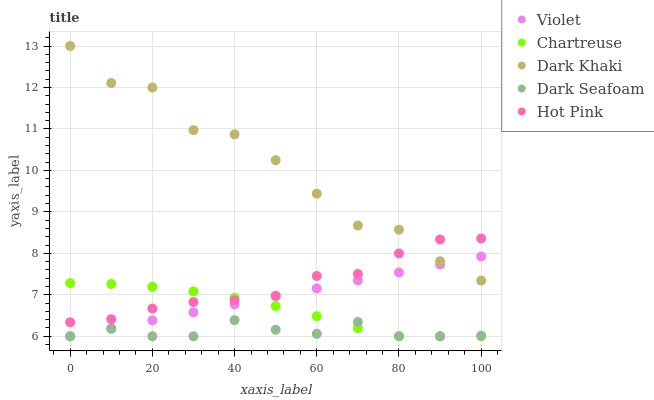Does Dark Seafoam have the minimum area under the curve?
Answer yes or no. Yes. Does Dark Khaki have the maximum area under the curve?
Answer yes or no. Yes. Does Chartreuse have the minimum area under the curve?
Answer yes or no. No. Does Chartreuse have the maximum area under the curve?
Answer yes or no. No. Is Violet the smoothest?
Answer yes or no. Yes. Is Dark Khaki the roughest?
Answer yes or no. Yes. Is Chartreuse the smoothest?
Answer yes or no. No. Is Chartreuse the roughest?
Answer yes or no. No. Does Chartreuse have the lowest value?
Answer yes or no. Yes. Does Hot Pink have the lowest value?
Answer yes or no. No. Does Dark Khaki have the highest value?
Answer yes or no. Yes. Does Chartreuse have the highest value?
Answer yes or no. No. Is Violet less than Hot Pink?
Answer yes or no. Yes. Is Hot Pink greater than Dark Seafoam?
Answer yes or no. Yes. Does Dark Khaki intersect Violet?
Answer yes or no. Yes. Is Dark Khaki less than Violet?
Answer yes or no. No. Is Dark Khaki greater than Violet?
Answer yes or no. No. Does Violet intersect Hot Pink?
Answer yes or no. No. 